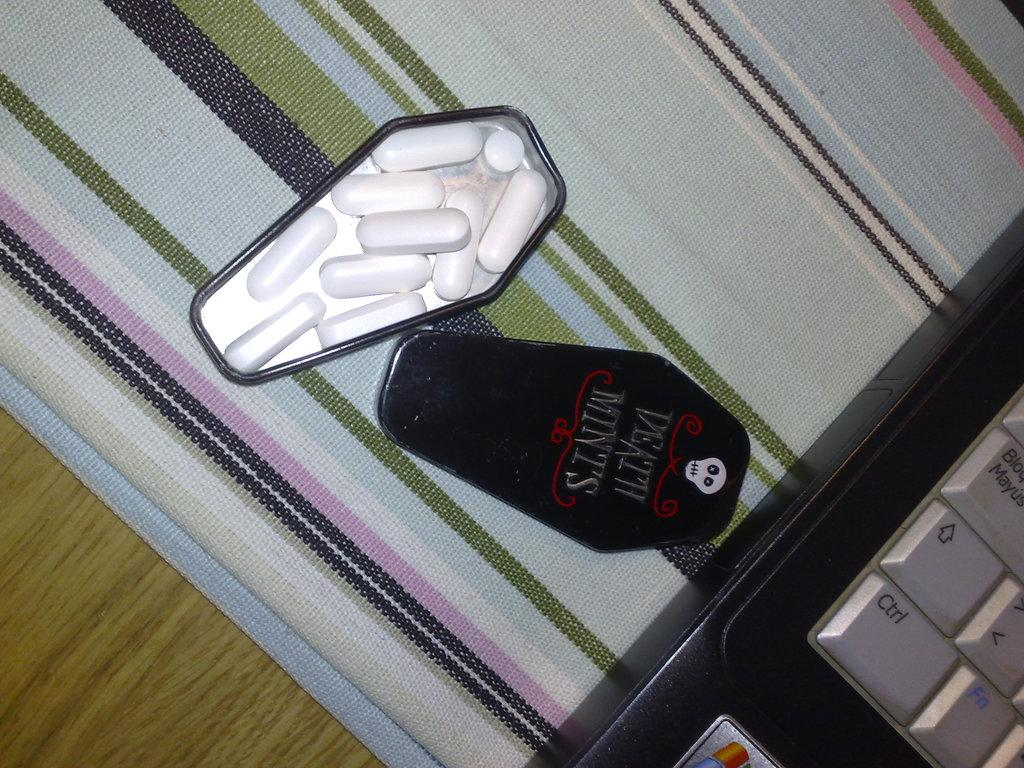<image>
Provide a brief description of the given image. A mint tin in the shape of a coffin has death mints written on the lid. 